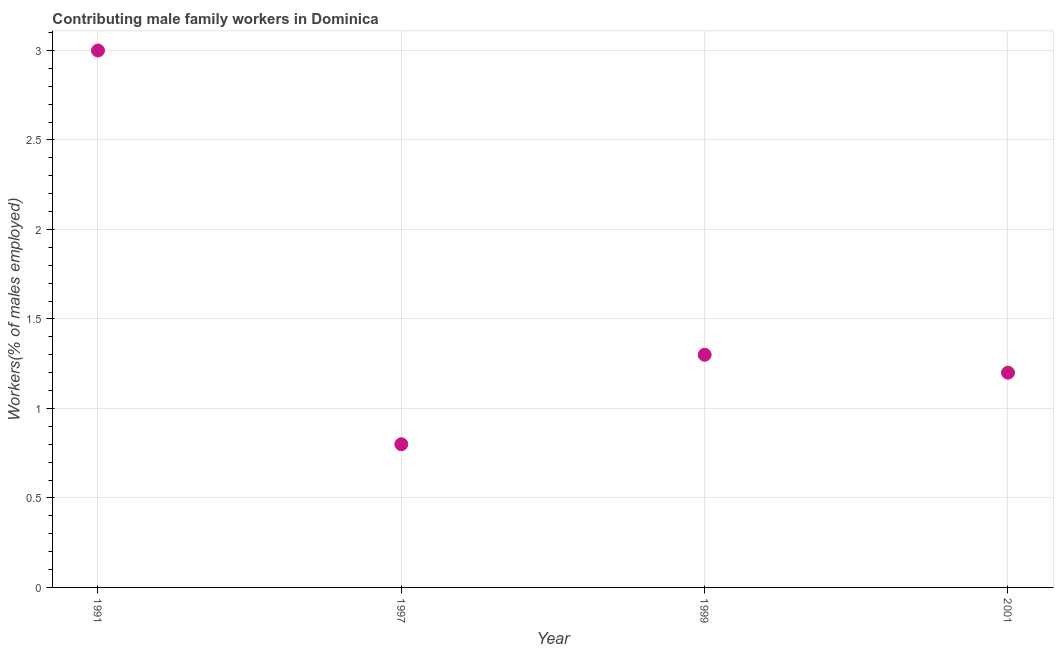What is the contributing male family workers in 2001?
Provide a short and direct response. 1.2. Across all years, what is the minimum contributing male family workers?
Make the answer very short. 0.8. What is the sum of the contributing male family workers?
Provide a succinct answer. 6.3. What is the difference between the contributing male family workers in 1997 and 1999?
Offer a very short reply. -0.5. What is the average contributing male family workers per year?
Offer a very short reply. 1.58. What is the ratio of the contributing male family workers in 1991 to that in 1997?
Your answer should be compact. 3.75. Is the contributing male family workers in 1999 less than that in 2001?
Your response must be concise. No. Is the difference between the contributing male family workers in 1999 and 2001 greater than the difference between any two years?
Your response must be concise. No. What is the difference between the highest and the second highest contributing male family workers?
Provide a succinct answer. 1.7. What is the difference between the highest and the lowest contributing male family workers?
Make the answer very short. 2.2. Does the contributing male family workers monotonically increase over the years?
Offer a very short reply. No. How many dotlines are there?
Make the answer very short. 1. How many years are there in the graph?
Offer a very short reply. 4. Are the values on the major ticks of Y-axis written in scientific E-notation?
Ensure brevity in your answer.  No. Does the graph contain grids?
Ensure brevity in your answer.  Yes. What is the title of the graph?
Offer a terse response. Contributing male family workers in Dominica. What is the label or title of the X-axis?
Offer a very short reply. Year. What is the label or title of the Y-axis?
Your answer should be compact. Workers(% of males employed). What is the Workers(% of males employed) in 1997?
Provide a succinct answer. 0.8. What is the Workers(% of males employed) in 1999?
Your answer should be very brief. 1.3. What is the Workers(% of males employed) in 2001?
Give a very brief answer. 1.2. What is the difference between the Workers(% of males employed) in 1991 and 1997?
Provide a succinct answer. 2.2. What is the difference between the Workers(% of males employed) in 1999 and 2001?
Make the answer very short. 0.1. What is the ratio of the Workers(% of males employed) in 1991 to that in 1997?
Provide a short and direct response. 3.75. What is the ratio of the Workers(% of males employed) in 1991 to that in 1999?
Ensure brevity in your answer.  2.31. What is the ratio of the Workers(% of males employed) in 1991 to that in 2001?
Ensure brevity in your answer.  2.5. What is the ratio of the Workers(% of males employed) in 1997 to that in 1999?
Offer a very short reply. 0.61. What is the ratio of the Workers(% of males employed) in 1997 to that in 2001?
Provide a short and direct response. 0.67. What is the ratio of the Workers(% of males employed) in 1999 to that in 2001?
Give a very brief answer. 1.08. 